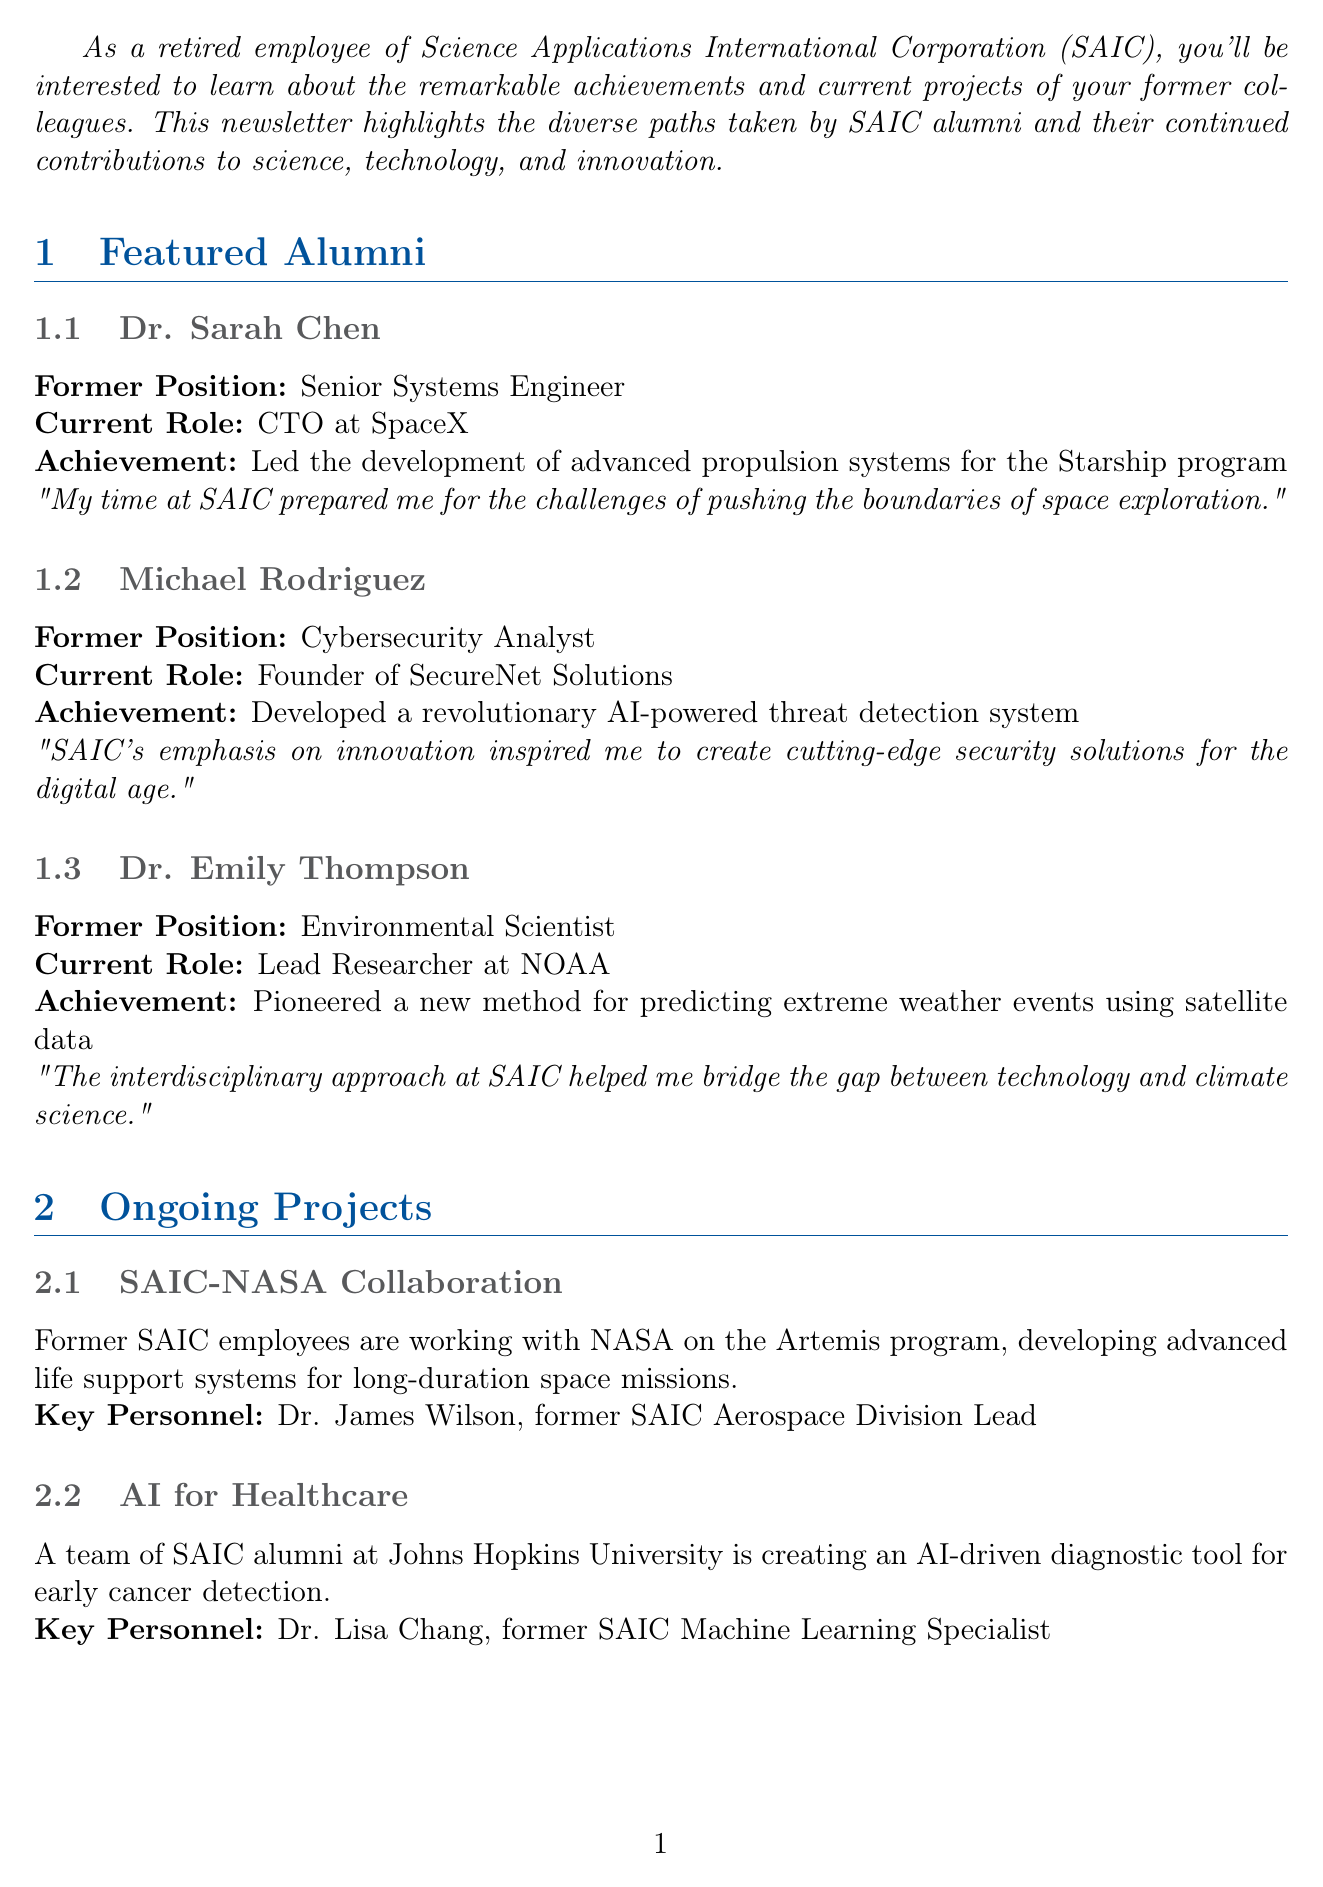What is the title of the newsletter? The title of the newsletter is explicitly stated at the beginning of the document.
Answer: SAIC Alumni Spotlight: Where Are They Now? Who is the current CTO at SpaceX? This information is found in the featured alumni section regarding Dr. Sarah Chen's current role.
Answer: Dr. Sarah Chen What achievement is Dr. Emily Thompson known for? The document specifically notes her significant contribution in the featured alumni section.
Answer: Pioneered a new method for predicting extreme weather events using satellite data When is the Annual SAIC Alumni Symposium taking place? The date for the event is mentioned in the alumni network update section of the newsletter.
Answer: September 15-17, 2023 Who is the keynote speaker for the symposium? This detail is provided in the alumni network update section and involves a notable individual connected to SAIC.
Answer: Dr. Robert Gates What is the focus of the SAIC-NASA collaboration project? The document describes the focus of this project in the ongoing projects section.
Answer: Developing advanced life support systems for long-duration space missions How many featured alumni are mentioned in the newsletter? By counting the entries in the featured alumni section, the number of individuals spotlighted can be determined.
Answer: Three What company is hiring for the position of Lead Data Scientist? The career opportunities section clearly lists the companies with open positions.
Answer: Booz Allen Hamilton Which key personnel is involved in the AI for Healthcare project? This detail can be found in the description of ongoing projects, specifically related to the alumni project.
Answer: Dr. Lisa Chang 